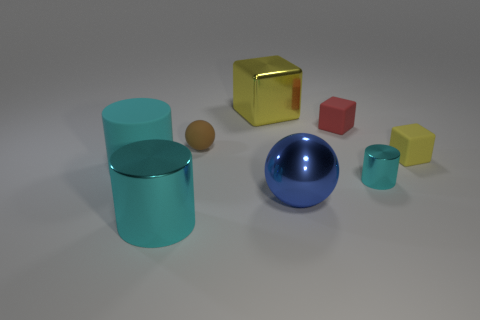How are the shadows in the image affected by the light source? The shadows in the image suggest a light source above and to the right, as indicated by the direction and length of the shadows cast by the objects. The shadows are softer and not overly pronounced, hinting at a diffused light source, potentially ambient or indirect lighting. 